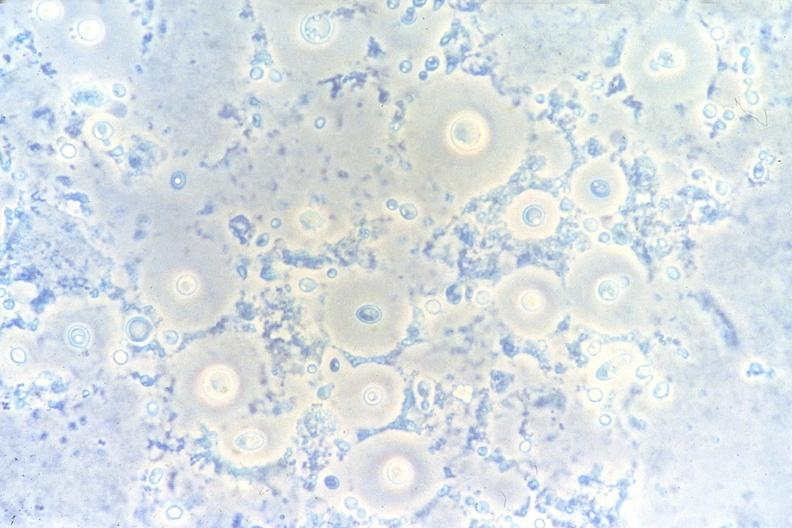does this image show lung, cryptococcal pneumonia, touch impression under phase contract?
Answer the question using a single word or phrase. Yes 